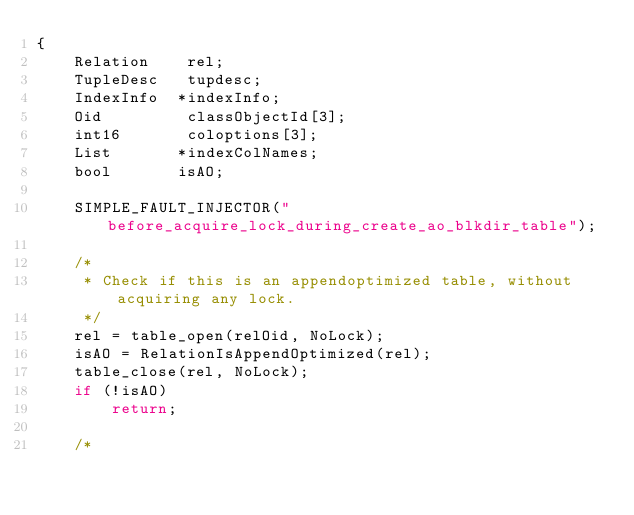<code> <loc_0><loc_0><loc_500><loc_500><_C_>{
	Relation	rel;
	TupleDesc	tupdesc;
	IndexInfo  *indexInfo;
	Oid			classObjectId[3];
	int16		coloptions[3];
	List	   *indexColNames;
	bool	   isAO;

	SIMPLE_FAULT_INJECTOR("before_acquire_lock_during_create_ao_blkdir_table");

	/*
	 * Check if this is an appendoptimized table, without acquiring any lock.
	 */
	rel = table_open(relOid, NoLock);
	isAO = RelationIsAppendOptimized(rel);
	table_close(rel, NoLock);
	if (!isAO)
		return;

	/*</code> 